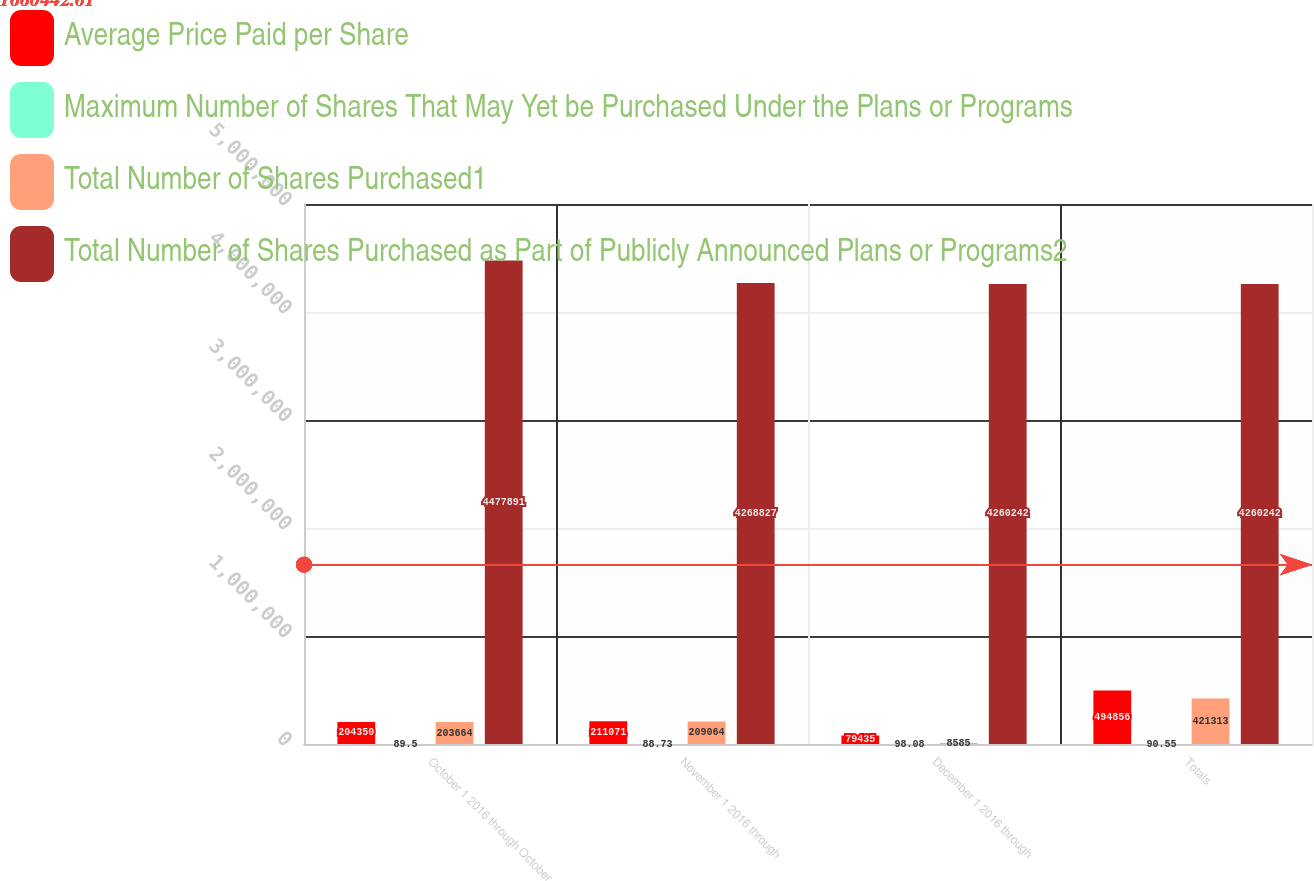Convert chart to OTSL. <chart><loc_0><loc_0><loc_500><loc_500><stacked_bar_chart><ecel><fcel>October 1 2016 through October<fcel>November 1 2016 through<fcel>December 1 2016 through<fcel>Totals<nl><fcel>Average Price Paid per Share<fcel>204350<fcel>211071<fcel>79435<fcel>494856<nl><fcel>Maximum Number of Shares That May Yet be Purchased Under the Plans or Programs<fcel>89.5<fcel>88.73<fcel>98.08<fcel>90.55<nl><fcel>Total Number of Shares Purchased1<fcel>203664<fcel>209064<fcel>8585<fcel>421313<nl><fcel>Total Number of Shares Purchased as Part of Publicly Announced Plans or Programs2<fcel>4.47789e+06<fcel>4.26883e+06<fcel>4.26024e+06<fcel>4.26024e+06<nl></chart> 